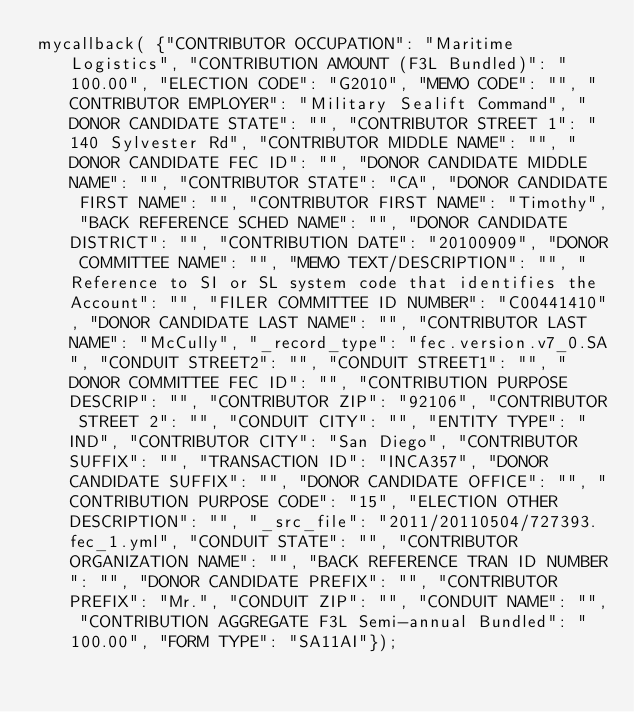Convert code to text. <code><loc_0><loc_0><loc_500><loc_500><_JavaScript_>mycallback( {"CONTRIBUTOR OCCUPATION": "Maritime Logistics", "CONTRIBUTION AMOUNT (F3L Bundled)": "100.00", "ELECTION CODE": "G2010", "MEMO CODE": "", "CONTRIBUTOR EMPLOYER": "Military Sealift Command", "DONOR CANDIDATE STATE": "", "CONTRIBUTOR STREET 1": "140 Sylvester Rd", "CONTRIBUTOR MIDDLE NAME": "", "DONOR CANDIDATE FEC ID": "", "DONOR CANDIDATE MIDDLE NAME": "", "CONTRIBUTOR STATE": "CA", "DONOR CANDIDATE FIRST NAME": "", "CONTRIBUTOR FIRST NAME": "Timothy", "BACK REFERENCE SCHED NAME": "", "DONOR CANDIDATE DISTRICT": "", "CONTRIBUTION DATE": "20100909", "DONOR COMMITTEE NAME": "", "MEMO TEXT/DESCRIPTION": "", "Reference to SI or SL system code that identifies the Account": "", "FILER COMMITTEE ID NUMBER": "C00441410", "DONOR CANDIDATE LAST NAME": "", "CONTRIBUTOR LAST NAME": "McCully", "_record_type": "fec.version.v7_0.SA", "CONDUIT STREET2": "", "CONDUIT STREET1": "", "DONOR COMMITTEE FEC ID": "", "CONTRIBUTION PURPOSE DESCRIP": "", "CONTRIBUTOR ZIP": "92106", "CONTRIBUTOR STREET 2": "", "CONDUIT CITY": "", "ENTITY TYPE": "IND", "CONTRIBUTOR CITY": "San Diego", "CONTRIBUTOR SUFFIX": "", "TRANSACTION ID": "INCA357", "DONOR CANDIDATE SUFFIX": "", "DONOR CANDIDATE OFFICE": "", "CONTRIBUTION PURPOSE CODE": "15", "ELECTION OTHER DESCRIPTION": "", "_src_file": "2011/20110504/727393.fec_1.yml", "CONDUIT STATE": "", "CONTRIBUTOR ORGANIZATION NAME": "", "BACK REFERENCE TRAN ID NUMBER": "", "DONOR CANDIDATE PREFIX": "", "CONTRIBUTOR PREFIX": "Mr.", "CONDUIT ZIP": "", "CONDUIT NAME": "", "CONTRIBUTION AGGREGATE F3L Semi-annual Bundled": "100.00", "FORM TYPE": "SA11AI"});
</code> 